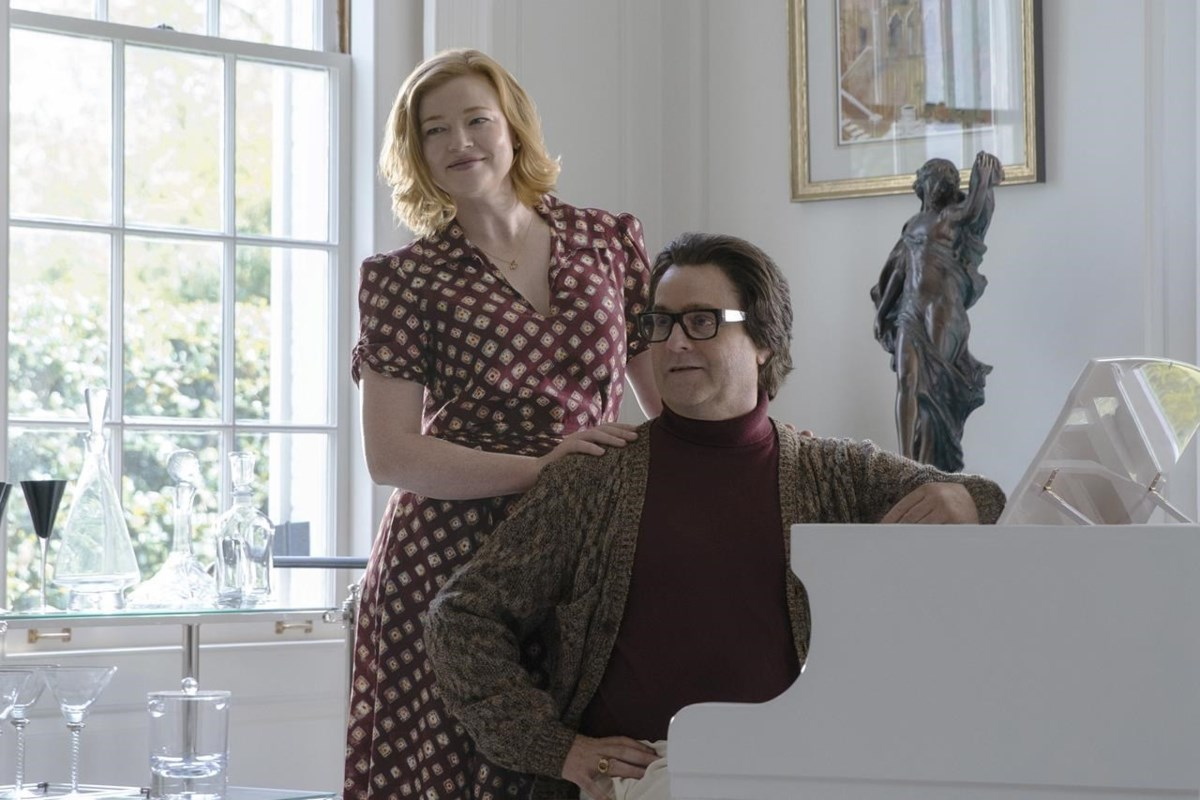If this image could tell a fantastical story, what would it be? In an enchanted world where music has the power to weave magic, this room is a secret hub where melodies bring stories to life. The man at the piano is not just playing music; he’s a sorcerer conjuring beautiful, vibrant scenes out of thin air with every note. His companion, once a graceful dancer from a distant realm, has been transformed back into her human form by the sorcerer's harmonious spell. The statue behind them is actually a guardian of artistic treasures, making sure that the magic remains undisturbed. Together, they create magical realms where time stands still, and every piece of art in the room bears witness to countless tales spun from tunes and dreams. 